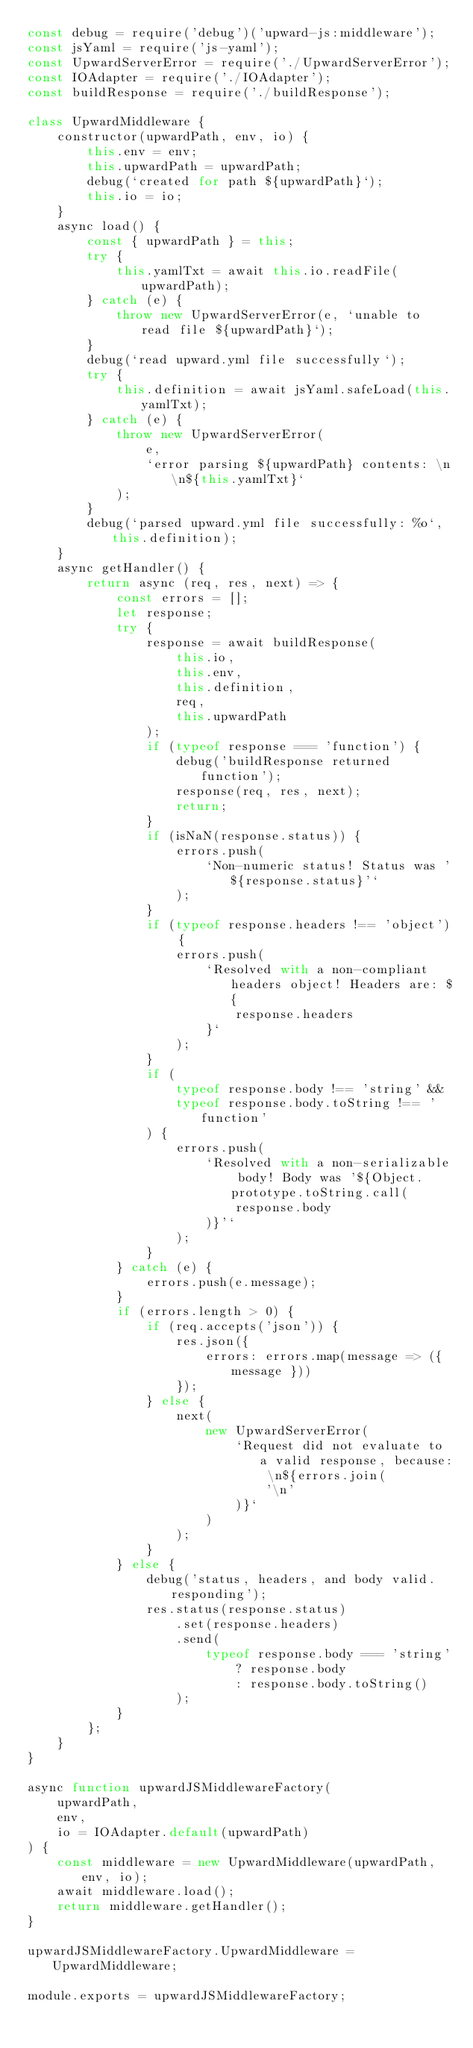<code> <loc_0><loc_0><loc_500><loc_500><_JavaScript_>const debug = require('debug')('upward-js:middleware');
const jsYaml = require('js-yaml');
const UpwardServerError = require('./UpwardServerError');
const IOAdapter = require('./IOAdapter');
const buildResponse = require('./buildResponse');

class UpwardMiddleware {
    constructor(upwardPath, env, io) {
        this.env = env;
        this.upwardPath = upwardPath;
        debug(`created for path ${upwardPath}`);
        this.io = io;
    }
    async load() {
        const { upwardPath } = this;
        try {
            this.yamlTxt = await this.io.readFile(upwardPath);
        } catch (e) {
            throw new UpwardServerError(e, `unable to read file ${upwardPath}`);
        }
        debug(`read upward.yml file successfully`);
        try {
            this.definition = await jsYaml.safeLoad(this.yamlTxt);
        } catch (e) {
            throw new UpwardServerError(
                e,
                `error parsing ${upwardPath} contents: \n\n${this.yamlTxt}`
            );
        }
        debug(`parsed upward.yml file successfully: %o`, this.definition);
    }
    async getHandler() {
        return async (req, res, next) => {
            const errors = [];
            let response;
            try {
                response = await buildResponse(
                    this.io,
                    this.env,
                    this.definition,
                    req,
                    this.upwardPath
                );
                if (typeof response === 'function') {
                    debug('buildResponse returned function');
                    response(req, res, next);
                    return;
                }
                if (isNaN(response.status)) {
                    errors.push(
                        `Non-numeric status! Status was '${response.status}'`
                    );
                }
                if (typeof response.headers !== 'object') {
                    errors.push(
                        `Resolved with a non-compliant headers object! Headers are: ${
                            response.headers
                        }`
                    );
                }
                if (
                    typeof response.body !== 'string' &&
                    typeof response.body.toString !== 'function'
                ) {
                    errors.push(
                        `Resolved with a non-serializable body! Body was '${Object.prototype.toString.call(
                            response.body
                        )}'`
                    );
                }
            } catch (e) {
                errors.push(e.message);
            }
            if (errors.length > 0) {
                if (req.accepts('json')) {
                    res.json({
                        errors: errors.map(message => ({ message }))
                    });
                } else {
                    next(
                        new UpwardServerError(
                            `Request did not evaluate to a valid response, because: \n${errors.join(
                                '\n'
                            )}`
                        )
                    );
                }
            } else {
                debug('status, headers, and body valid. responding');
                res.status(response.status)
                    .set(response.headers)
                    .send(
                        typeof response.body === 'string'
                            ? response.body
                            : response.body.toString()
                    );
            }
        };
    }
}

async function upwardJSMiddlewareFactory(
    upwardPath,
    env,
    io = IOAdapter.default(upwardPath)
) {
    const middleware = new UpwardMiddleware(upwardPath, env, io);
    await middleware.load();
    return middleware.getHandler();
}

upwardJSMiddlewareFactory.UpwardMiddleware = UpwardMiddleware;

module.exports = upwardJSMiddlewareFactory;
</code> 